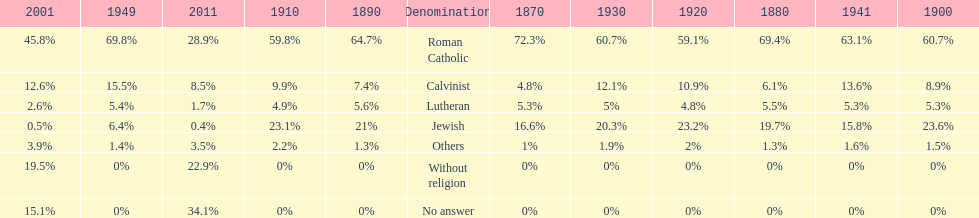Which religious denomination had a higher percentage in 1900, jewish or roman catholic? Roman Catholic. 